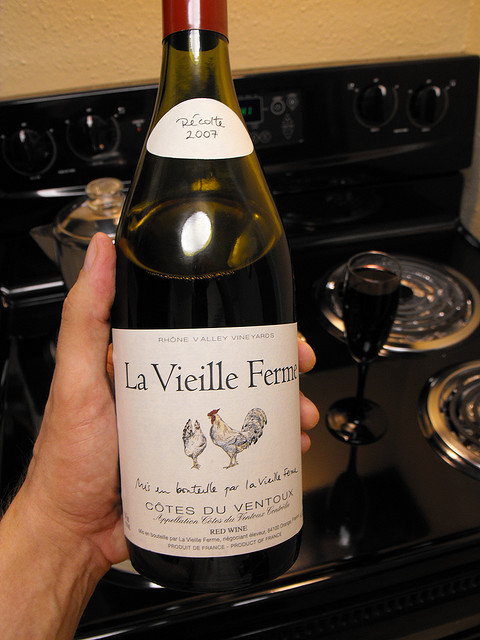Identify and read out the text in this image. COTES DU VENTOUX La TO FRANCE WINE RED la benteille VINO VALLEY PHONE Ferme 2007 